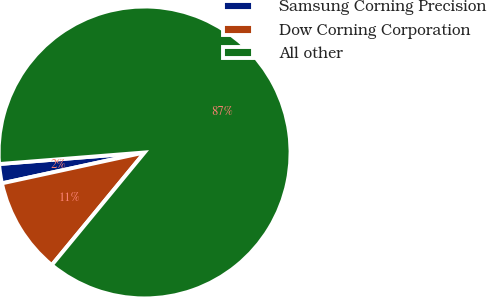Convert chart to OTSL. <chart><loc_0><loc_0><loc_500><loc_500><pie_chart><fcel>Samsung Corning Precision<fcel>Dow Corning Corporation<fcel>All other<nl><fcel>2.13%<fcel>10.64%<fcel>87.23%<nl></chart> 